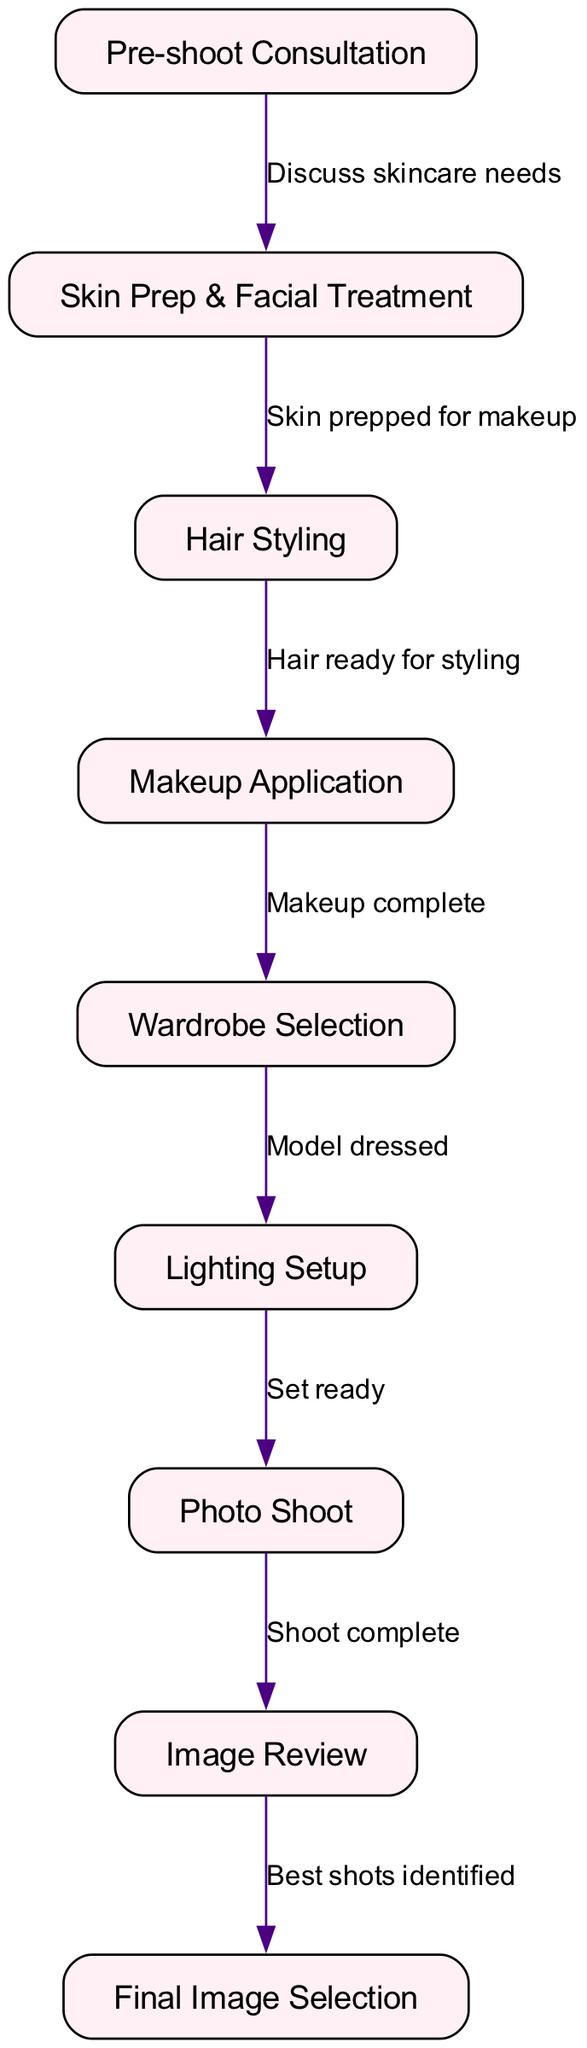What is the first stage in the diagram? The first stage listed in the diagram is "Pre-shoot Consultation." It is the starting point and every other stage follows after consulting about the shoot details.
Answer: Pre-shoot Consultation How many nodes are in the diagram? Counting each unique stage or step, there are 9 nodes depicted in the diagram representing different stages of the photoshoot process.
Answer: 9 What stage comes after Skin Prep & Facial Treatment? According to the edges in the diagram, after "Skin Prep & Facial Treatment," the next stage is "Hair Styling," showing the order of operations in the photoshoot process.
Answer: Hair Styling What is the relationship between Makeup Application and Wardrobe Selection? The edge connecting "Makeup Application" to "Wardrobe Selection" indicates that "Makeup complete" leads to the dressing of the model, illustrating a sequential connection in the photoshoot workflow.
Answer: Makeup complete How many edges are there in the diagram? The edges represent the connections and relationships between the stages. By counting them, there are 8 edges connecting the 9 nodes sequentially in the photoshoot process.
Answer: 8 What step occurs immediately before the Photo Shoot? The diagram shows that "Lighting Setup" occurs right before the "Photo Shoot," setting up the space effectively to capture images.
Answer: Lighting Setup What is the last stage in the process? The final stage shown in the diagram is "Final Image Selection," where the best shots are chosen after the review phase.
Answer: Final Image Selection What does the edge between Image Review and Final Image Selection represent? This edge signifies that after "Image Review," the next action to take is identifying the best shots, marking a decision-making process in selecting images.
Answer: Best shots identified Which node indicates that the model is dressed? The diagram indicates that "Wardrobe Selection" denotes when the model is dressed, as it is directly related to this specific stage.
Answer: Wardrobe Selection 